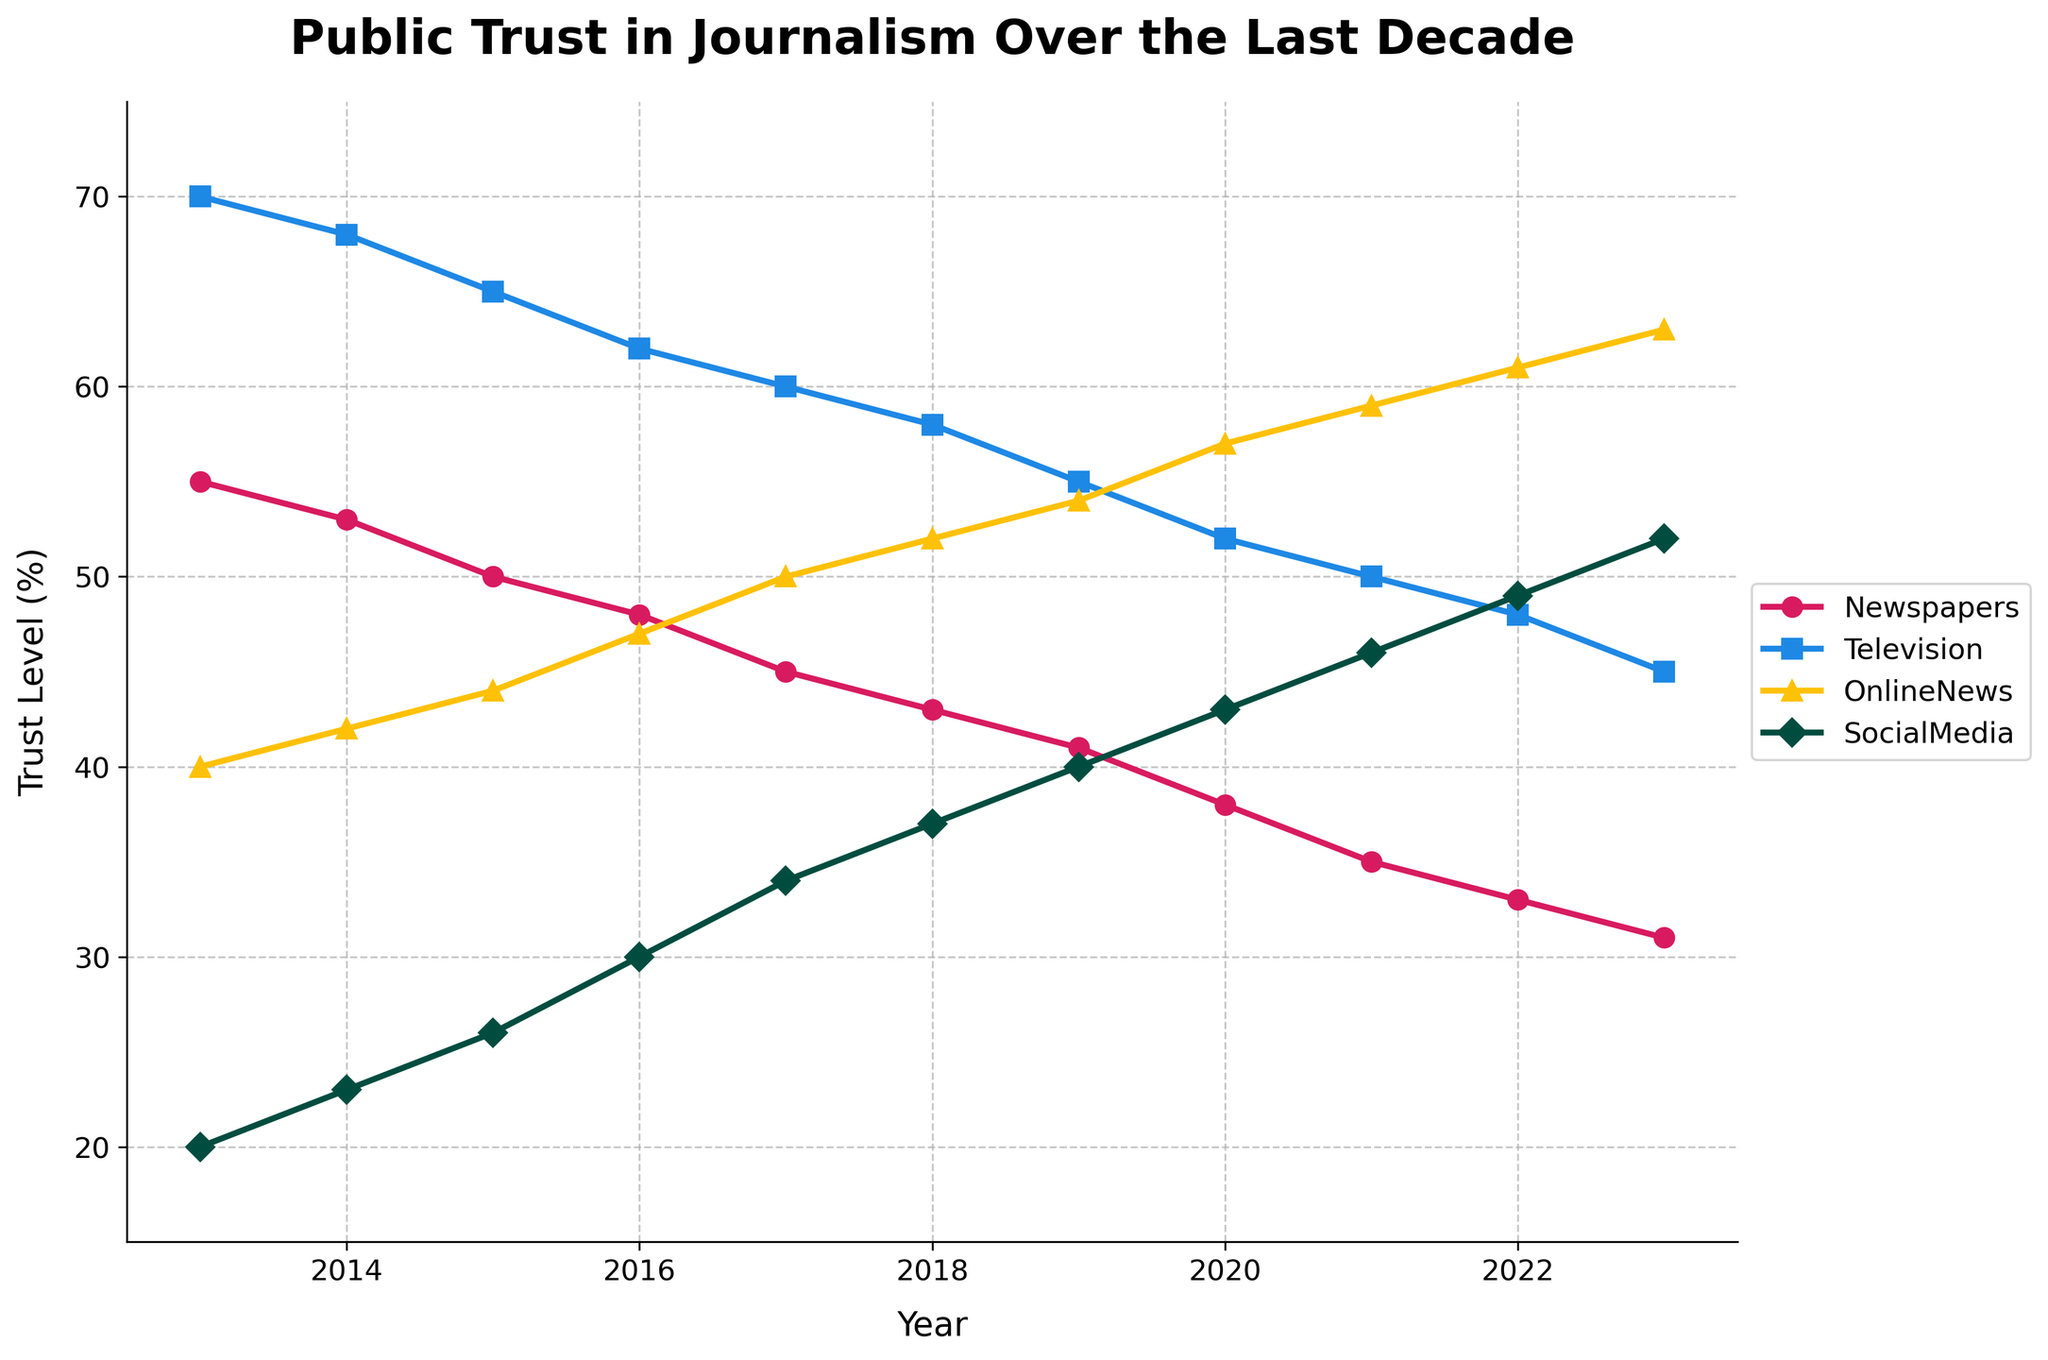What's the title of the plot? The title of the plot is displayed at the top of the figure.
Answer: Public Trust in Journalism Over the Last Decade Which media outlet had the highest trust level in 2013? The plot shows the trust levels for different media outlets in 2013. The outlet with the highest value in that year is Television.
Answer: Television How did the trust level in Social Media change from 2013 to 2023? To determine the change, find the values for Social Media in 2013 and 2023, then calculate the difference: 52 (2023) - 20 (2013) = 32.
Answer: Increased by 32 What is the average trust level for Online News over the decade? Sum the trust levels for each year and divide by the number of years. (40 + 42 + 44 + 47 + 50 + 52 + 54 + 57 + 59 + 61 + 63) / 11 = 52.
Answer: 52 Which media outlet showed a consistent decline in trust level over the decade? Examine the trends for each outlet and identify the one with consistently decreasing values. Newspapers consistently declined each year.
Answer: Newspapers In which year did Online News surpass Television in trust level? Compare the trust levels for Online News and Television year by year. Online News surpassed Television in 2020 when Online News had 57 and Television had 52.
Answer: 2020 What is the difference in the trust level between Newspapers and Social Media in 2023? Look at the values for both in 2023 and subtract the trust level for Newspapers from that of Social Media: 52 (Social Media) - 31 (Newspapers) = 21.
Answer: 21 Between 2013 and 2023, which media outlet had the most significant increase in trust level? Calculate the change for each outlet from 2013 to 2023 and identify the greatest increase: Social Media changed by (52 - 20) = 32.
Answer: Social Media Which year had the smallest difference in trust levels between Newspapers and Television? Find the differences between the two outlets for each year and identify the smallest difference. In 2023, the difference is smallest: 45 (Television) - 31 (Newspapers) = 14.
Answer: 2023 Is there any year when all media outlets either increased or decreased in trust level compared to the previous year? Examine year-over-year changes for consistency in direction. From 2017 to 2018, all outlets decreased in trust level.
Answer: 2017 to 2018 Which media outlet had the highest average trust level over the decade? Calculate the average trust level for each outlet and compare them. Television has the highest average: (70 + 68 + 65 + 62 + 60 + 58 + 55 + 52 + 50 + 48 + 45) / 11 = 57.
Answer: Television 